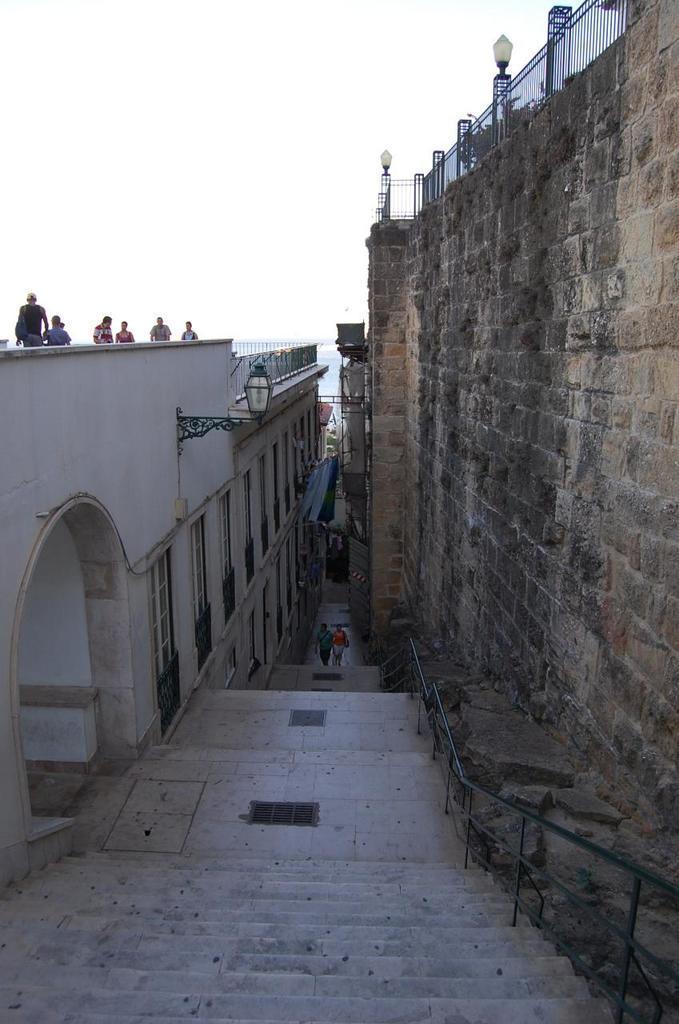Could you give a brief overview of what you see in this image? This image consists of steps. To the right, there is a wall. To the left, there is a building on which there are persons. At the top, there is a sky. 